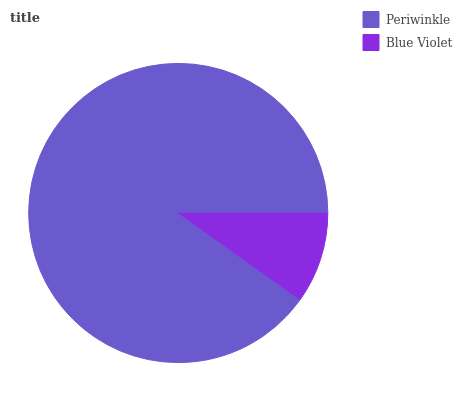Is Blue Violet the minimum?
Answer yes or no. Yes. Is Periwinkle the maximum?
Answer yes or no. Yes. Is Blue Violet the maximum?
Answer yes or no. No. Is Periwinkle greater than Blue Violet?
Answer yes or no. Yes. Is Blue Violet less than Periwinkle?
Answer yes or no. Yes. Is Blue Violet greater than Periwinkle?
Answer yes or no. No. Is Periwinkle less than Blue Violet?
Answer yes or no. No. Is Periwinkle the high median?
Answer yes or no. Yes. Is Blue Violet the low median?
Answer yes or no. Yes. Is Blue Violet the high median?
Answer yes or no. No. Is Periwinkle the low median?
Answer yes or no. No. 